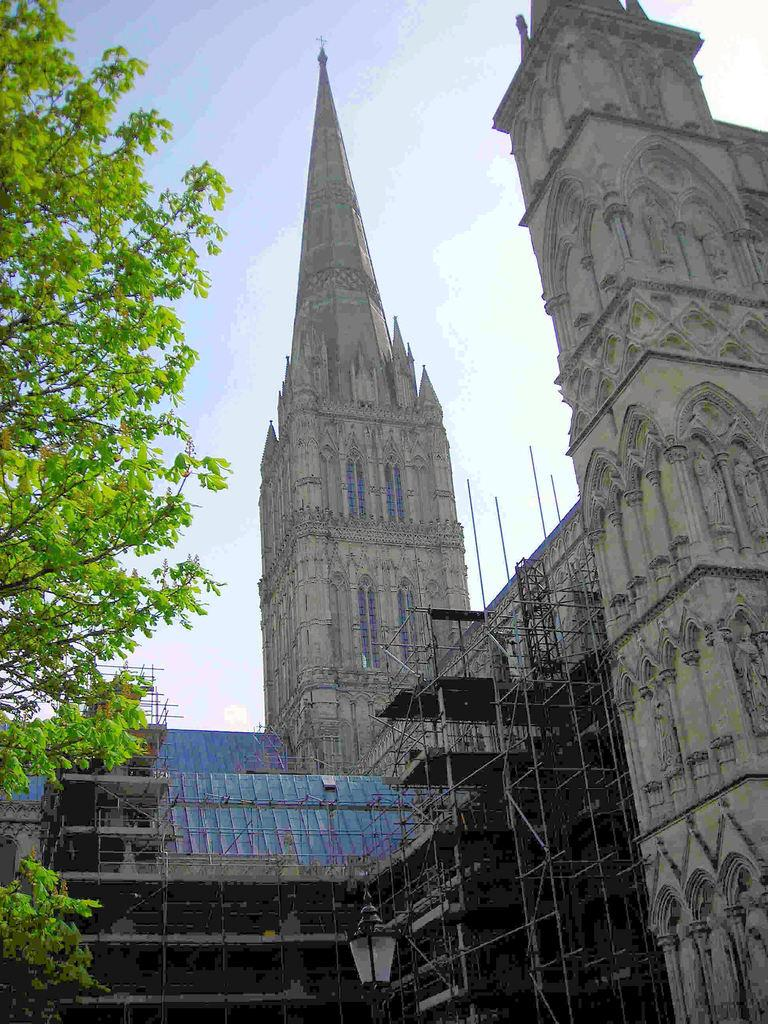What type of structure is in the image? There is a castle in the image. What color is the castle? The castle is grey in color. Where is the castle located in the image? The castle is towards the right side of the image. What other natural element is in the image? There is a tree in the image. Where is the tree located in the image? The tree is towards the left side of the image. What is visible in the background of the image? There is a sky visible in the image, and clouds are present in the sky. What type of cushion is being used to support the chain in the image? There is no cushion or chain present in the image. 